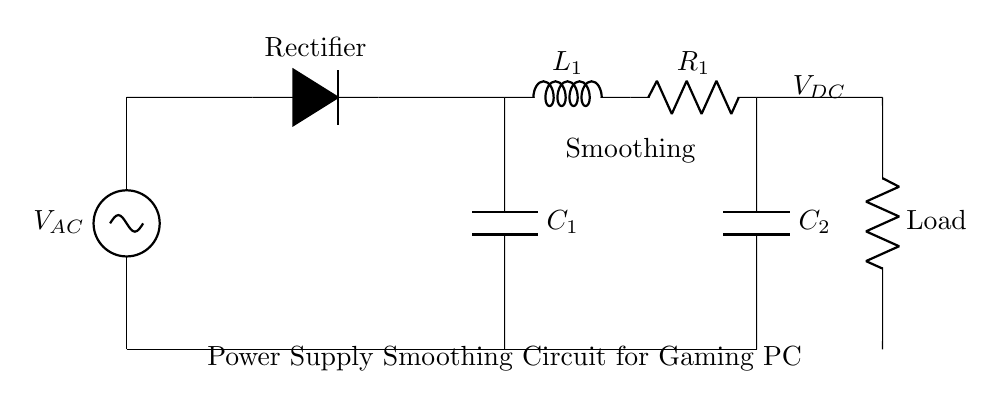What is the function of C1 in this circuit? Capacitor C1 is a smoothing capacitor that reduces the ripple voltage from the rectified AC, providing a smoother voltage to downstream components.
Answer: Smoothing What is the purpose of L1? Inductor L1 is used to further smooth the output current by opposing changes in current, thereby reducing ripple and fluctuations.
Answer: Smoothing What type of load is indicated in this circuit? The load is represented by a resistor, which in this case can be a simulated load for testing the power supply's output.
Answer: Resistor What is the voltage at the output labeled V_DC? The output voltage is typically a direct current voltage that has been smoothed from the rectified AC, but the exact value isn't specified in the circuit.
Answer: V_DC is not specified What components are needed to form a power supply smoothing circuit? The components needed are a capacitor, an inductor, a resistor, along with a rectifier for converting AC to DC.
Answer: Capacitor, inductor, resistor What does the rectifier do in this circuit? The rectifier converts the alternating current (AC) from the power supply into direct current (DC), which is necessary for the operation of a gaming PC.
Answer: Converts AC to DC 